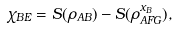Convert formula to latex. <formula><loc_0><loc_0><loc_500><loc_500>\chi _ { B E } = S ( \rho _ { A B } ) - S ( \rho _ { A F G } ^ { x _ { B } } ) ,</formula> 